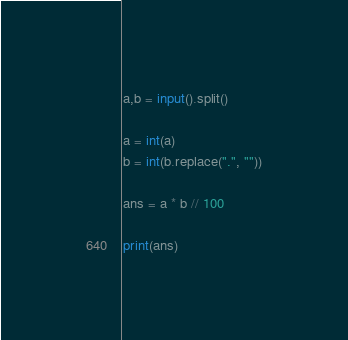Convert code to text. <code><loc_0><loc_0><loc_500><loc_500><_Python_>a,b = input().split()

a = int(a)
b = int(b.replace(".", ""))

ans = a * b // 100

print(ans)</code> 